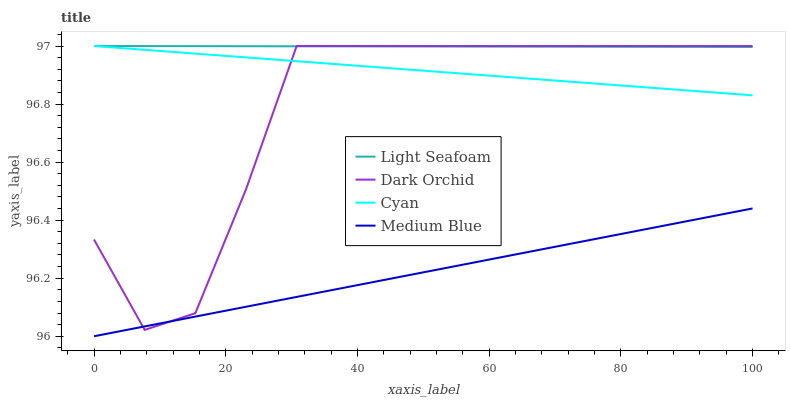Does Medium Blue have the minimum area under the curve?
Answer yes or no. Yes. Does Light Seafoam have the maximum area under the curve?
Answer yes or no. Yes. Does Light Seafoam have the minimum area under the curve?
Answer yes or no. No. Does Medium Blue have the maximum area under the curve?
Answer yes or no. No. Is Cyan the smoothest?
Answer yes or no. Yes. Is Dark Orchid the roughest?
Answer yes or no. Yes. Is Light Seafoam the smoothest?
Answer yes or no. No. Is Light Seafoam the roughest?
Answer yes or no. No. Does Medium Blue have the lowest value?
Answer yes or no. Yes. Does Light Seafoam have the lowest value?
Answer yes or no. No. Does Dark Orchid have the highest value?
Answer yes or no. Yes. Does Medium Blue have the highest value?
Answer yes or no. No. Is Medium Blue less than Light Seafoam?
Answer yes or no. Yes. Is Cyan greater than Medium Blue?
Answer yes or no. Yes. Does Dark Orchid intersect Medium Blue?
Answer yes or no. Yes. Is Dark Orchid less than Medium Blue?
Answer yes or no. No. Is Dark Orchid greater than Medium Blue?
Answer yes or no. No. Does Medium Blue intersect Light Seafoam?
Answer yes or no. No. 